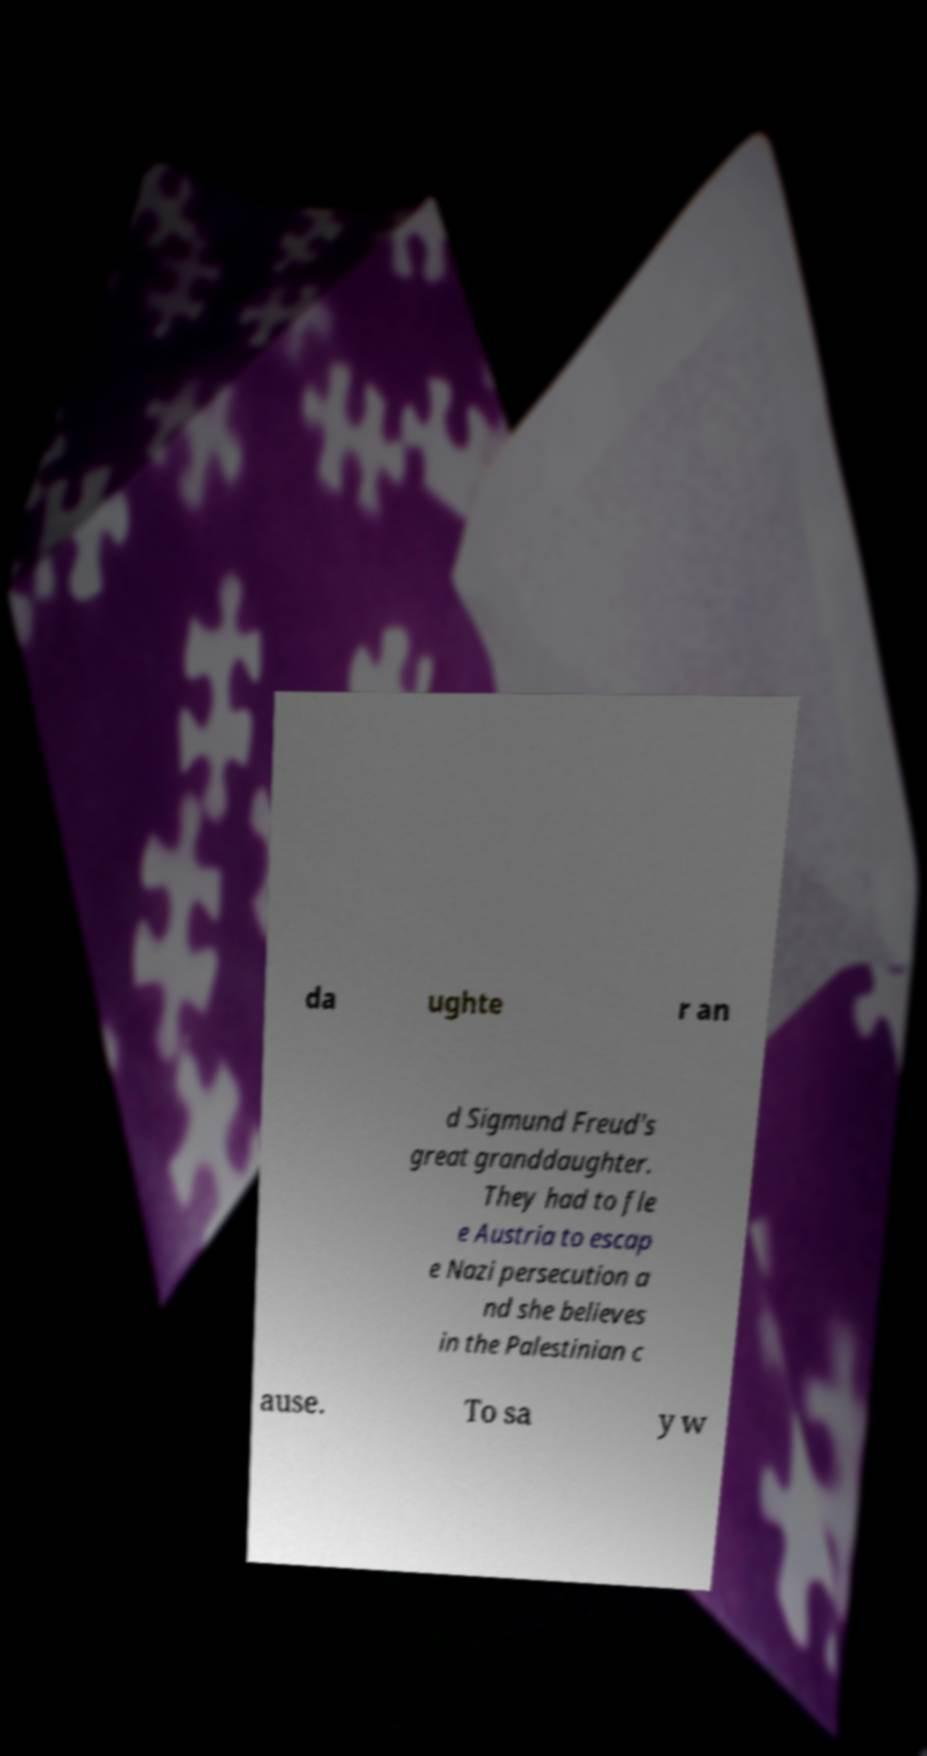What messages or text are displayed in this image? I need them in a readable, typed format. da ughte r an d Sigmund Freud's great granddaughter. They had to fle e Austria to escap e Nazi persecution a nd she believes in the Palestinian c ause. To sa y w 